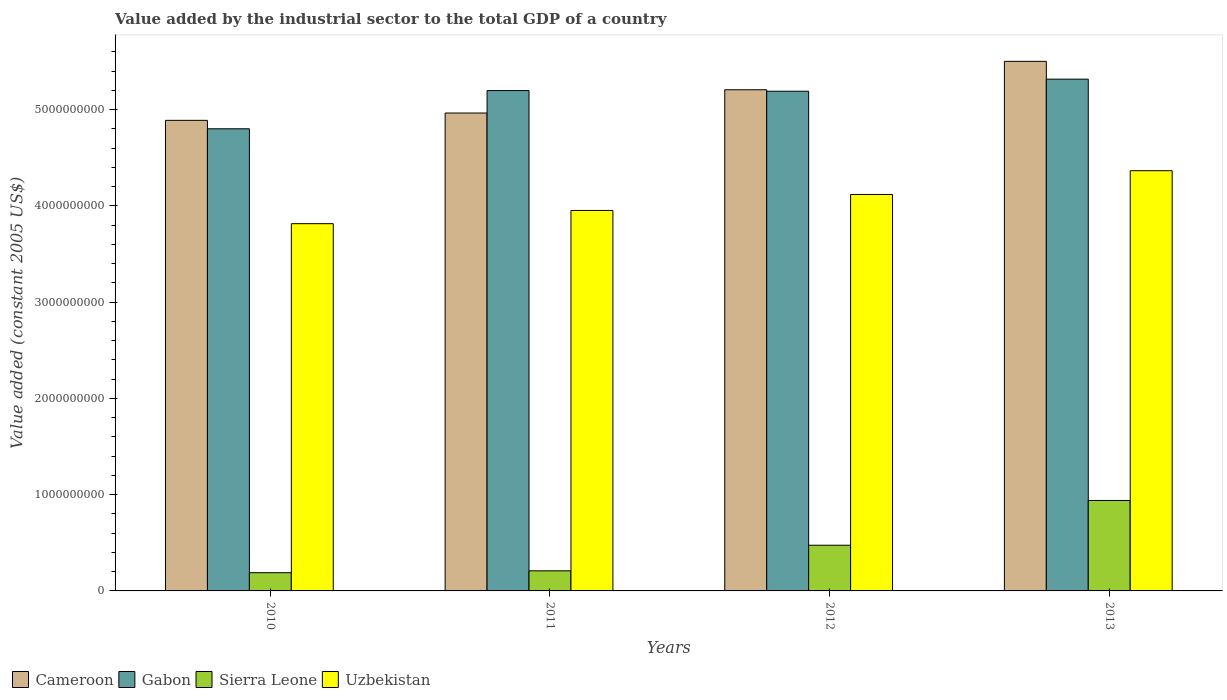How many different coloured bars are there?
Offer a terse response. 4. How many groups of bars are there?
Your answer should be very brief. 4. Are the number of bars per tick equal to the number of legend labels?
Make the answer very short. Yes. Are the number of bars on each tick of the X-axis equal?
Your answer should be compact. Yes. What is the label of the 3rd group of bars from the left?
Provide a short and direct response. 2012. In how many cases, is the number of bars for a given year not equal to the number of legend labels?
Your response must be concise. 0. What is the value added by the industrial sector in Gabon in 2011?
Offer a terse response. 5.20e+09. Across all years, what is the maximum value added by the industrial sector in Cameroon?
Ensure brevity in your answer.  5.50e+09. Across all years, what is the minimum value added by the industrial sector in Sierra Leone?
Provide a short and direct response. 1.89e+08. What is the total value added by the industrial sector in Uzbekistan in the graph?
Provide a short and direct response. 1.62e+1. What is the difference between the value added by the industrial sector in Sierra Leone in 2010 and that in 2011?
Offer a very short reply. -1.94e+07. What is the difference between the value added by the industrial sector in Gabon in 2011 and the value added by the industrial sector in Sierra Leone in 2010?
Your answer should be very brief. 5.01e+09. What is the average value added by the industrial sector in Gabon per year?
Offer a very short reply. 5.13e+09. In the year 2013, what is the difference between the value added by the industrial sector in Cameroon and value added by the industrial sector in Sierra Leone?
Provide a short and direct response. 4.56e+09. In how many years, is the value added by the industrial sector in Uzbekistan greater than 2000000000 US$?
Keep it short and to the point. 4. What is the ratio of the value added by the industrial sector in Uzbekistan in 2010 to that in 2012?
Your response must be concise. 0.93. Is the difference between the value added by the industrial sector in Cameroon in 2012 and 2013 greater than the difference between the value added by the industrial sector in Sierra Leone in 2012 and 2013?
Your answer should be compact. Yes. What is the difference between the highest and the second highest value added by the industrial sector in Uzbekistan?
Give a very brief answer. 2.47e+08. What is the difference between the highest and the lowest value added by the industrial sector in Uzbekistan?
Ensure brevity in your answer.  5.50e+08. Is it the case that in every year, the sum of the value added by the industrial sector in Cameroon and value added by the industrial sector in Gabon is greater than the sum of value added by the industrial sector in Uzbekistan and value added by the industrial sector in Sierra Leone?
Your response must be concise. Yes. What does the 4th bar from the left in 2011 represents?
Make the answer very short. Uzbekistan. What does the 1st bar from the right in 2013 represents?
Your answer should be very brief. Uzbekistan. How many bars are there?
Give a very brief answer. 16. Are the values on the major ticks of Y-axis written in scientific E-notation?
Provide a succinct answer. No. Does the graph contain grids?
Provide a succinct answer. No. How many legend labels are there?
Provide a short and direct response. 4. How are the legend labels stacked?
Your response must be concise. Horizontal. What is the title of the graph?
Provide a short and direct response. Value added by the industrial sector to the total GDP of a country. What is the label or title of the X-axis?
Your answer should be compact. Years. What is the label or title of the Y-axis?
Make the answer very short. Value added (constant 2005 US$). What is the Value added (constant 2005 US$) in Cameroon in 2010?
Provide a succinct answer. 4.89e+09. What is the Value added (constant 2005 US$) in Gabon in 2010?
Keep it short and to the point. 4.80e+09. What is the Value added (constant 2005 US$) in Sierra Leone in 2010?
Your answer should be compact. 1.89e+08. What is the Value added (constant 2005 US$) in Uzbekistan in 2010?
Ensure brevity in your answer.  3.81e+09. What is the Value added (constant 2005 US$) in Cameroon in 2011?
Your answer should be compact. 4.96e+09. What is the Value added (constant 2005 US$) of Gabon in 2011?
Provide a short and direct response. 5.20e+09. What is the Value added (constant 2005 US$) of Sierra Leone in 2011?
Make the answer very short. 2.09e+08. What is the Value added (constant 2005 US$) in Uzbekistan in 2011?
Provide a succinct answer. 3.95e+09. What is the Value added (constant 2005 US$) of Cameroon in 2012?
Your answer should be very brief. 5.21e+09. What is the Value added (constant 2005 US$) of Gabon in 2012?
Provide a short and direct response. 5.19e+09. What is the Value added (constant 2005 US$) of Sierra Leone in 2012?
Your answer should be compact. 4.75e+08. What is the Value added (constant 2005 US$) of Uzbekistan in 2012?
Keep it short and to the point. 4.12e+09. What is the Value added (constant 2005 US$) in Cameroon in 2013?
Your answer should be very brief. 5.50e+09. What is the Value added (constant 2005 US$) of Gabon in 2013?
Your answer should be very brief. 5.32e+09. What is the Value added (constant 2005 US$) in Sierra Leone in 2013?
Give a very brief answer. 9.39e+08. What is the Value added (constant 2005 US$) in Uzbekistan in 2013?
Make the answer very short. 4.37e+09. Across all years, what is the maximum Value added (constant 2005 US$) in Cameroon?
Offer a very short reply. 5.50e+09. Across all years, what is the maximum Value added (constant 2005 US$) in Gabon?
Keep it short and to the point. 5.32e+09. Across all years, what is the maximum Value added (constant 2005 US$) of Sierra Leone?
Offer a very short reply. 9.39e+08. Across all years, what is the maximum Value added (constant 2005 US$) of Uzbekistan?
Your answer should be very brief. 4.37e+09. Across all years, what is the minimum Value added (constant 2005 US$) in Cameroon?
Offer a terse response. 4.89e+09. Across all years, what is the minimum Value added (constant 2005 US$) of Gabon?
Your answer should be very brief. 4.80e+09. Across all years, what is the minimum Value added (constant 2005 US$) of Sierra Leone?
Your answer should be compact. 1.89e+08. Across all years, what is the minimum Value added (constant 2005 US$) of Uzbekistan?
Give a very brief answer. 3.81e+09. What is the total Value added (constant 2005 US$) in Cameroon in the graph?
Offer a terse response. 2.06e+1. What is the total Value added (constant 2005 US$) in Gabon in the graph?
Give a very brief answer. 2.05e+1. What is the total Value added (constant 2005 US$) in Sierra Leone in the graph?
Give a very brief answer. 1.81e+09. What is the total Value added (constant 2005 US$) in Uzbekistan in the graph?
Ensure brevity in your answer.  1.62e+1. What is the difference between the Value added (constant 2005 US$) of Cameroon in 2010 and that in 2011?
Offer a very short reply. -7.62e+07. What is the difference between the Value added (constant 2005 US$) of Gabon in 2010 and that in 2011?
Provide a short and direct response. -3.97e+08. What is the difference between the Value added (constant 2005 US$) in Sierra Leone in 2010 and that in 2011?
Make the answer very short. -1.94e+07. What is the difference between the Value added (constant 2005 US$) in Uzbekistan in 2010 and that in 2011?
Your answer should be very brief. -1.37e+08. What is the difference between the Value added (constant 2005 US$) of Cameroon in 2010 and that in 2012?
Ensure brevity in your answer.  -3.18e+08. What is the difference between the Value added (constant 2005 US$) of Gabon in 2010 and that in 2012?
Make the answer very short. -3.90e+08. What is the difference between the Value added (constant 2005 US$) in Sierra Leone in 2010 and that in 2012?
Provide a succinct answer. -2.85e+08. What is the difference between the Value added (constant 2005 US$) in Uzbekistan in 2010 and that in 2012?
Provide a succinct answer. -3.03e+08. What is the difference between the Value added (constant 2005 US$) of Cameroon in 2010 and that in 2013?
Offer a terse response. -6.13e+08. What is the difference between the Value added (constant 2005 US$) in Gabon in 2010 and that in 2013?
Provide a succinct answer. -5.16e+08. What is the difference between the Value added (constant 2005 US$) of Sierra Leone in 2010 and that in 2013?
Make the answer very short. -7.50e+08. What is the difference between the Value added (constant 2005 US$) of Uzbekistan in 2010 and that in 2013?
Make the answer very short. -5.50e+08. What is the difference between the Value added (constant 2005 US$) in Cameroon in 2011 and that in 2012?
Make the answer very short. -2.42e+08. What is the difference between the Value added (constant 2005 US$) in Gabon in 2011 and that in 2012?
Ensure brevity in your answer.  6.56e+06. What is the difference between the Value added (constant 2005 US$) in Sierra Leone in 2011 and that in 2012?
Offer a terse response. -2.66e+08. What is the difference between the Value added (constant 2005 US$) of Uzbekistan in 2011 and that in 2012?
Your answer should be compact. -1.66e+08. What is the difference between the Value added (constant 2005 US$) of Cameroon in 2011 and that in 2013?
Make the answer very short. -5.37e+08. What is the difference between the Value added (constant 2005 US$) of Gabon in 2011 and that in 2013?
Offer a very short reply. -1.19e+08. What is the difference between the Value added (constant 2005 US$) in Sierra Leone in 2011 and that in 2013?
Your response must be concise. -7.31e+08. What is the difference between the Value added (constant 2005 US$) in Uzbekistan in 2011 and that in 2013?
Make the answer very short. -4.13e+08. What is the difference between the Value added (constant 2005 US$) in Cameroon in 2012 and that in 2013?
Your response must be concise. -2.95e+08. What is the difference between the Value added (constant 2005 US$) in Gabon in 2012 and that in 2013?
Your answer should be compact. -1.25e+08. What is the difference between the Value added (constant 2005 US$) of Sierra Leone in 2012 and that in 2013?
Your answer should be very brief. -4.65e+08. What is the difference between the Value added (constant 2005 US$) of Uzbekistan in 2012 and that in 2013?
Provide a short and direct response. -2.47e+08. What is the difference between the Value added (constant 2005 US$) of Cameroon in 2010 and the Value added (constant 2005 US$) of Gabon in 2011?
Your response must be concise. -3.09e+08. What is the difference between the Value added (constant 2005 US$) in Cameroon in 2010 and the Value added (constant 2005 US$) in Sierra Leone in 2011?
Offer a terse response. 4.68e+09. What is the difference between the Value added (constant 2005 US$) of Cameroon in 2010 and the Value added (constant 2005 US$) of Uzbekistan in 2011?
Give a very brief answer. 9.36e+08. What is the difference between the Value added (constant 2005 US$) of Gabon in 2010 and the Value added (constant 2005 US$) of Sierra Leone in 2011?
Offer a very short reply. 4.59e+09. What is the difference between the Value added (constant 2005 US$) of Gabon in 2010 and the Value added (constant 2005 US$) of Uzbekistan in 2011?
Offer a terse response. 8.48e+08. What is the difference between the Value added (constant 2005 US$) in Sierra Leone in 2010 and the Value added (constant 2005 US$) in Uzbekistan in 2011?
Your response must be concise. -3.76e+09. What is the difference between the Value added (constant 2005 US$) of Cameroon in 2010 and the Value added (constant 2005 US$) of Gabon in 2012?
Keep it short and to the point. -3.03e+08. What is the difference between the Value added (constant 2005 US$) in Cameroon in 2010 and the Value added (constant 2005 US$) in Sierra Leone in 2012?
Make the answer very short. 4.41e+09. What is the difference between the Value added (constant 2005 US$) of Cameroon in 2010 and the Value added (constant 2005 US$) of Uzbekistan in 2012?
Offer a terse response. 7.70e+08. What is the difference between the Value added (constant 2005 US$) of Gabon in 2010 and the Value added (constant 2005 US$) of Sierra Leone in 2012?
Ensure brevity in your answer.  4.33e+09. What is the difference between the Value added (constant 2005 US$) of Gabon in 2010 and the Value added (constant 2005 US$) of Uzbekistan in 2012?
Your answer should be compact. 6.82e+08. What is the difference between the Value added (constant 2005 US$) of Sierra Leone in 2010 and the Value added (constant 2005 US$) of Uzbekistan in 2012?
Keep it short and to the point. -3.93e+09. What is the difference between the Value added (constant 2005 US$) in Cameroon in 2010 and the Value added (constant 2005 US$) in Gabon in 2013?
Your answer should be very brief. -4.28e+08. What is the difference between the Value added (constant 2005 US$) in Cameroon in 2010 and the Value added (constant 2005 US$) in Sierra Leone in 2013?
Offer a terse response. 3.95e+09. What is the difference between the Value added (constant 2005 US$) of Cameroon in 2010 and the Value added (constant 2005 US$) of Uzbekistan in 2013?
Provide a short and direct response. 5.23e+08. What is the difference between the Value added (constant 2005 US$) of Gabon in 2010 and the Value added (constant 2005 US$) of Sierra Leone in 2013?
Offer a very short reply. 3.86e+09. What is the difference between the Value added (constant 2005 US$) in Gabon in 2010 and the Value added (constant 2005 US$) in Uzbekistan in 2013?
Your response must be concise. 4.35e+08. What is the difference between the Value added (constant 2005 US$) in Sierra Leone in 2010 and the Value added (constant 2005 US$) in Uzbekistan in 2013?
Your answer should be compact. -4.18e+09. What is the difference between the Value added (constant 2005 US$) of Cameroon in 2011 and the Value added (constant 2005 US$) of Gabon in 2012?
Ensure brevity in your answer.  -2.26e+08. What is the difference between the Value added (constant 2005 US$) in Cameroon in 2011 and the Value added (constant 2005 US$) in Sierra Leone in 2012?
Your answer should be very brief. 4.49e+09. What is the difference between the Value added (constant 2005 US$) of Cameroon in 2011 and the Value added (constant 2005 US$) of Uzbekistan in 2012?
Offer a terse response. 8.46e+08. What is the difference between the Value added (constant 2005 US$) in Gabon in 2011 and the Value added (constant 2005 US$) in Sierra Leone in 2012?
Your answer should be very brief. 4.72e+09. What is the difference between the Value added (constant 2005 US$) of Gabon in 2011 and the Value added (constant 2005 US$) of Uzbekistan in 2012?
Give a very brief answer. 1.08e+09. What is the difference between the Value added (constant 2005 US$) of Sierra Leone in 2011 and the Value added (constant 2005 US$) of Uzbekistan in 2012?
Provide a short and direct response. -3.91e+09. What is the difference between the Value added (constant 2005 US$) of Cameroon in 2011 and the Value added (constant 2005 US$) of Gabon in 2013?
Make the answer very short. -3.52e+08. What is the difference between the Value added (constant 2005 US$) of Cameroon in 2011 and the Value added (constant 2005 US$) of Sierra Leone in 2013?
Ensure brevity in your answer.  4.02e+09. What is the difference between the Value added (constant 2005 US$) in Cameroon in 2011 and the Value added (constant 2005 US$) in Uzbekistan in 2013?
Keep it short and to the point. 5.99e+08. What is the difference between the Value added (constant 2005 US$) in Gabon in 2011 and the Value added (constant 2005 US$) in Sierra Leone in 2013?
Ensure brevity in your answer.  4.26e+09. What is the difference between the Value added (constant 2005 US$) of Gabon in 2011 and the Value added (constant 2005 US$) of Uzbekistan in 2013?
Provide a succinct answer. 8.32e+08. What is the difference between the Value added (constant 2005 US$) in Sierra Leone in 2011 and the Value added (constant 2005 US$) in Uzbekistan in 2013?
Keep it short and to the point. -4.16e+09. What is the difference between the Value added (constant 2005 US$) of Cameroon in 2012 and the Value added (constant 2005 US$) of Gabon in 2013?
Your answer should be very brief. -1.10e+08. What is the difference between the Value added (constant 2005 US$) of Cameroon in 2012 and the Value added (constant 2005 US$) of Sierra Leone in 2013?
Your response must be concise. 4.27e+09. What is the difference between the Value added (constant 2005 US$) in Cameroon in 2012 and the Value added (constant 2005 US$) in Uzbekistan in 2013?
Your answer should be compact. 8.41e+08. What is the difference between the Value added (constant 2005 US$) of Gabon in 2012 and the Value added (constant 2005 US$) of Sierra Leone in 2013?
Provide a short and direct response. 4.25e+09. What is the difference between the Value added (constant 2005 US$) in Gabon in 2012 and the Value added (constant 2005 US$) in Uzbekistan in 2013?
Offer a terse response. 8.25e+08. What is the difference between the Value added (constant 2005 US$) of Sierra Leone in 2012 and the Value added (constant 2005 US$) of Uzbekistan in 2013?
Ensure brevity in your answer.  -3.89e+09. What is the average Value added (constant 2005 US$) of Cameroon per year?
Make the answer very short. 5.14e+09. What is the average Value added (constant 2005 US$) in Gabon per year?
Keep it short and to the point. 5.13e+09. What is the average Value added (constant 2005 US$) in Sierra Leone per year?
Provide a succinct answer. 4.53e+08. What is the average Value added (constant 2005 US$) in Uzbekistan per year?
Ensure brevity in your answer.  4.06e+09. In the year 2010, what is the difference between the Value added (constant 2005 US$) in Cameroon and Value added (constant 2005 US$) in Gabon?
Your response must be concise. 8.77e+07. In the year 2010, what is the difference between the Value added (constant 2005 US$) of Cameroon and Value added (constant 2005 US$) of Sierra Leone?
Provide a short and direct response. 4.70e+09. In the year 2010, what is the difference between the Value added (constant 2005 US$) of Cameroon and Value added (constant 2005 US$) of Uzbekistan?
Your answer should be very brief. 1.07e+09. In the year 2010, what is the difference between the Value added (constant 2005 US$) in Gabon and Value added (constant 2005 US$) in Sierra Leone?
Keep it short and to the point. 4.61e+09. In the year 2010, what is the difference between the Value added (constant 2005 US$) of Gabon and Value added (constant 2005 US$) of Uzbekistan?
Ensure brevity in your answer.  9.86e+08. In the year 2010, what is the difference between the Value added (constant 2005 US$) of Sierra Leone and Value added (constant 2005 US$) of Uzbekistan?
Your answer should be compact. -3.63e+09. In the year 2011, what is the difference between the Value added (constant 2005 US$) of Cameroon and Value added (constant 2005 US$) of Gabon?
Provide a short and direct response. -2.33e+08. In the year 2011, what is the difference between the Value added (constant 2005 US$) in Cameroon and Value added (constant 2005 US$) in Sierra Leone?
Provide a succinct answer. 4.76e+09. In the year 2011, what is the difference between the Value added (constant 2005 US$) of Cameroon and Value added (constant 2005 US$) of Uzbekistan?
Your answer should be very brief. 1.01e+09. In the year 2011, what is the difference between the Value added (constant 2005 US$) in Gabon and Value added (constant 2005 US$) in Sierra Leone?
Make the answer very short. 4.99e+09. In the year 2011, what is the difference between the Value added (constant 2005 US$) of Gabon and Value added (constant 2005 US$) of Uzbekistan?
Provide a short and direct response. 1.25e+09. In the year 2011, what is the difference between the Value added (constant 2005 US$) of Sierra Leone and Value added (constant 2005 US$) of Uzbekistan?
Provide a short and direct response. -3.74e+09. In the year 2012, what is the difference between the Value added (constant 2005 US$) of Cameroon and Value added (constant 2005 US$) of Gabon?
Your response must be concise. 1.52e+07. In the year 2012, what is the difference between the Value added (constant 2005 US$) of Cameroon and Value added (constant 2005 US$) of Sierra Leone?
Your answer should be compact. 4.73e+09. In the year 2012, what is the difference between the Value added (constant 2005 US$) of Cameroon and Value added (constant 2005 US$) of Uzbekistan?
Give a very brief answer. 1.09e+09. In the year 2012, what is the difference between the Value added (constant 2005 US$) of Gabon and Value added (constant 2005 US$) of Sierra Leone?
Provide a short and direct response. 4.72e+09. In the year 2012, what is the difference between the Value added (constant 2005 US$) in Gabon and Value added (constant 2005 US$) in Uzbekistan?
Provide a short and direct response. 1.07e+09. In the year 2012, what is the difference between the Value added (constant 2005 US$) in Sierra Leone and Value added (constant 2005 US$) in Uzbekistan?
Offer a terse response. -3.64e+09. In the year 2013, what is the difference between the Value added (constant 2005 US$) in Cameroon and Value added (constant 2005 US$) in Gabon?
Your response must be concise. 1.85e+08. In the year 2013, what is the difference between the Value added (constant 2005 US$) of Cameroon and Value added (constant 2005 US$) of Sierra Leone?
Ensure brevity in your answer.  4.56e+09. In the year 2013, what is the difference between the Value added (constant 2005 US$) in Cameroon and Value added (constant 2005 US$) in Uzbekistan?
Give a very brief answer. 1.14e+09. In the year 2013, what is the difference between the Value added (constant 2005 US$) of Gabon and Value added (constant 2005 US$) of Sierra Leone?
Offer a terse response. 4.38e+09. In the year 2013, what is the difference between the Value added (constant 2005 US$) of Gabon and Value added (constant 2005 US$) of Uzbekistan?
Give a very brief answer. 9.51e+08. In the year 2013, what is the difference between the Value added (constant 2005 US$) of Sierra Leone and Value added (constant 2005 US$) of Uzbekistan?
Your answer should be very brief. -3.43e+09. What is the ratio of the Value added (constant 2005 US$) in Cameroon in 2010 to that in 2011?
Your response must be concise. 0.98. What is the ratio of the Value added (constant 2005 US$) of Gabon in 2010 to that in 2011?
Provide a short and direct response. 0.92. What is the ratio of the Value added (constant 2005 US$) of Sierra Leone in 2010 to that in 2011?
Your response must be concise. 0.91. What is the ratio of the Value added (constant 2005 US$) in Uzbekistan in 2010 to that in 2011?
Make the answer very short. 0.97. What is the ratio of the Value added (constant 2005 US$) in Cameroon in 2010 to that in 2012?
Provide a short and direct response. 0.94. What is the ratio of the Value added (constant 2005 US$) of Gabon in 2010 to that in 2012?
Ensure brevity in your answer.  0.92. What is the ratio of the Value added (constant 2005 US$) of Sierra Leone in 2010 to that in 2012?
Your response must be concise. 0.4. What is the ratio of the Value added (constant 2005 US$) in Uzbekistan in 2010 to that in 2012?
Keep it short and to the point. 0.93. What is the ratio of the Value added (constant 2005 US$) of Cameroon in 2010 to that in 2013?
Your answer should be very brief. 0.89. What is the ratio of the Value added (constant 2005 US$) of Gabon in 2010 to that in 2013?
Provide a short and direct response. 0.9. What is the ratio of the Value added (constant 2005 US$) of Sierra Leone in 2010 to that in 2013?
Provide a succinct answer. 0.2. What is the ratio of the Value added (constant 2005 US$) in Uzbekistan in 2010 to that in 2013?
Offer a terse response. 0.87. What is the ratio of the Value added (constant 2005 US$) in Cameroon in 2011 to that in 2012?
Offer a terse response. 0.95. What is the ratio of the Value added (constant 2005 US$) in Sierra Leone in 2011 to that in 2012?
Give a very brief answer. 0.44. What is the ratio of the Value added (constant 2005 US$) of Uzbekistan in 2011 to that in 2012?
Ensure brevity in your answer.  0.96. What is the ratio of the Value added (constant 2005 US$) of Cameroon in 2011 to that in 2013?
Offer a very short reply. 0.9. What is the ratio of the Value added (constant 2005 US$) in Gabon in 2011 to that in 2013?
Your answer should be compact. 0.98. What is the ratio of the Value added (constant 2005 US$) in Sierra Leone in 2011 to that in 2013?
Your answer should be compact. 0.22. What is the ratio of the Value added (constant 2005 US$) of Uzbekistan in 2011 to that in 2013?
Provide a short and direct response. 0.91. What is the ratio of the Value added (constant 2005 US$) of Cameroon in 2012 to that in 2013?
Your response must be concise. 0.95. What is the ratio of the Value added (constant 2005 US$) in Gabon in 2012 to that in 2013?
Your answer should be very brief. 0.98. What is the ratio of the Value added (constant 2005 US$) of Sierra Leone in 2012 to that in 2013?
Provide a succinct answer. 0.51. What is the ratio of the Value added (constant 2005 US$) in Uzbekistan in 2012 to that in 2013?
Ensure brevity in your answer.  0.94. What is the difference between the highest and the second highest Value added (constant 2005 US$) in Cameroon?
Your answer should be very brief. 2.95e+08. What is the difference between the highest and the second highest Value added (constant 2005 US$) of Gabon?
Your answer should be very brief. 1.19e+08. What is the difference between the highest and the second highest Value added (constant 2005 US$) of Sierra Leone?
Your response must be concise. 4.65e+08. What is the difference between the highest and the second highest Value added (constant 2005 US$) of Uzbekistan?
Offer a very short reply. 2.47e+08. What is the difference between the highest and the lowest Value added (constant 2005 US$) of Cameroon?
Ensure brevity in your answer.  6.13e+08. What is the difference between the highest and the lowest Value added (constant 2005 US$) in Gabon?
Provide a short and direct response. 5.16e+08. What is the difference between the highest and the lowest Value added (constant 2005 US$) in Sierra Leone?
Your answer should be compact. 7.50e+08. What is the difference between the highest and the lowest Value added (constant 2005 US$) of Uzbekistan?
Your answer should be very brief. 5.50e+08. 